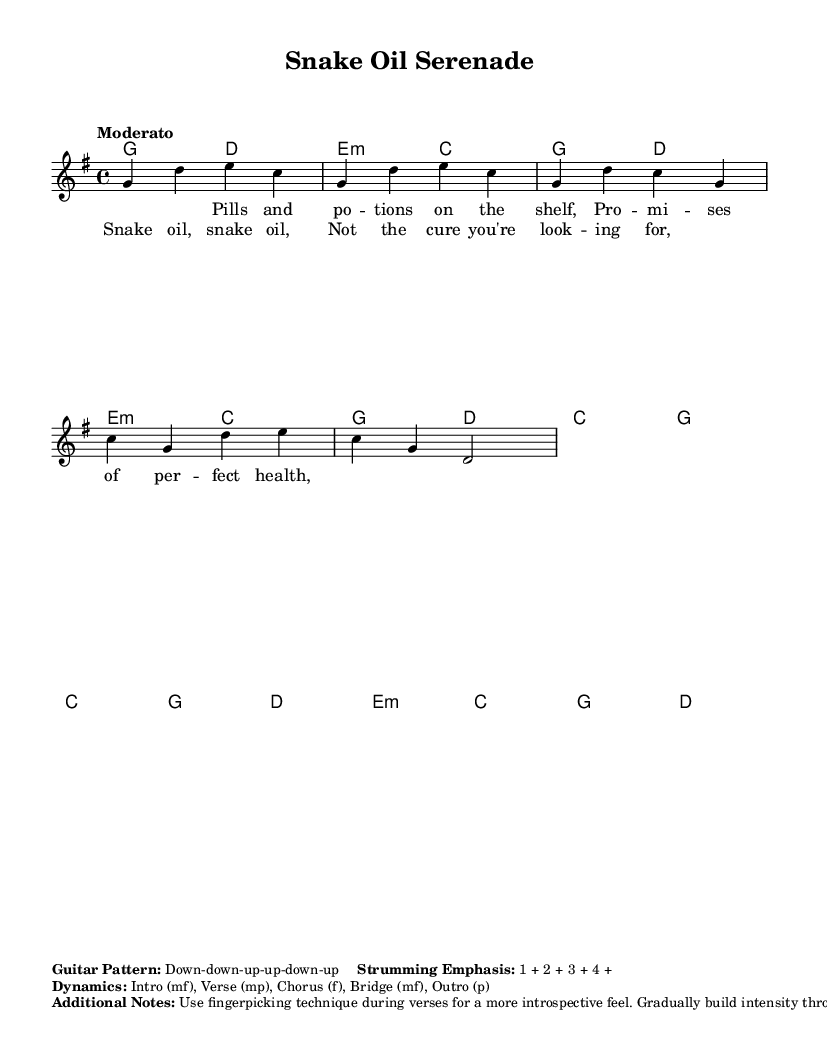What is the key signature of this music? The key signature is G major, which has one sharp (F#). This can be identified from the key signature indicated at the beginning of the sheet music.
Answer: G major What is the time signature of this piece? The time signature is 4/4, which is indicated at the start of the sheet music. This means there are four beats in each measure and the quarter note gets one beat.
Answer: 4/4 What is the tempo of this song? The tempo marking is "Moderato," which suggests a moderate pace for the performance. This information is located near the beginning of the music sheet, guiding the speed of the piece.
Answer: Moderato What is the dynamic level of the chorus? The dynamic level of the chorus is marked as "f," which signifies "forte," meaning to play loud. This is indicated in the dynamics section of the sheet music.
Answer: f How many measures are in the provided melody? The melody provided in the excerpt has a total of 8 measures. This can be counted by looking at the notation on the staff, where each measure is separated by a vertical bar.
Answer: 8 What technique is suggested for the verses? The technique suggested for the verses is "fingerpicking." This is noted in the additional remarks on the sheet, indicating a stylistic choice for playing during the verses to create an introspective feel.
Answer: Fingerpicking What is the primary theme of the lyrics? The primary theme of the lyrics addresses health misinformation and the false promises of dietary supplements, which is reflected in the lines about pills and potions. This thematic element is clear from the lyrics provided in the sheet music.
Answer: Health misinformation 